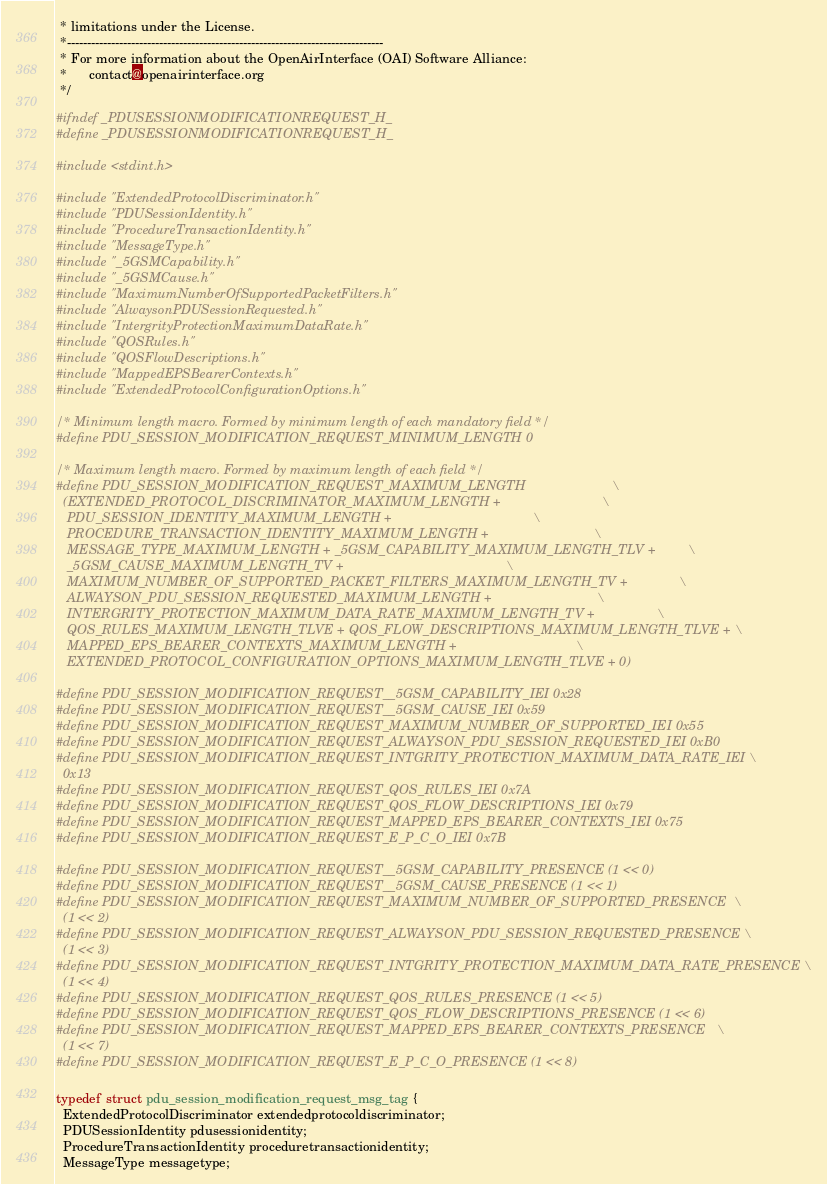Convert code to text. <code><loc_0><loc_0><loc_500><loc_500><_C_> * limitations under the License.
 *-------------------------------------------------------------------------------
 * For more information about the OpenAirInterface (OAI) Software Alliance:
 *      contact@openairinterface.org
 */

#ifndef _PDUSESSIONMODIFICATIONREQUEST_H_
#define _PDUSESSIONMODIFICATIONREQUEST_H_

#include <stdint.h>

#include "ExtendedProtocolDiscriminator.h"
#include "PDUSessionIdentity.h"
#include "ProcedureTransactionIdentity.h"
#include "MessageType.h"
#include "_5GSMCapability.h"
#include "_5GSMCause.h"
#include "MaximumNumberOfSupportedPacketFilters.h"
#include "AlwaysonPDUSessionRequested.h"
#include "IntergrityProtectionMaximumDataRate.h"
#include "QOSRules.h"
#include "QOSFlowDescriptions.h"
#include "MappedEPSBearerContexts.h"
#include "ExtendedProtocolConfigurationOptions.h"

/* Minimum length macro. Formed by minimum length of each mandatory field */
#define PDU_SESSION_MODIFICATION_REQUEST_MINIMUM_LENGTH 0

/* Maximum length macro. Formed by maximum length of each field */
#define PDU_SESSION_MODIFICATION_REQUEST_MAXIMUM_LENGTH                        \
  (EXTENDED_PROTOCOL_DISCRIMINATOR_MAXIMUM_LENGTH +                            \
   PDU_SESSION_IDENTITY_MAXIMUM_LENGTH +                                       \
   PROCEDURE_TRANSACTION_IDENTITY_MAXIMUM_LENGTH +                             \
   MESSAGE_TYPE_MAXIMUM_LENGTH + _5GSM_CAPABILITY_MAXIMUM_LENGTH_TLV +         \
   _5GSM_CAUSE_MAXIMUM_LENGTH_TV +                                             \
   MAXIMUM_NUMBER_OF_SUPPORTED_PACKET_FILTERS_MAXIMUM_LENGTH_TV +              \
   ALWAYSON_PDU_SESSION_REQUESTED_MAXIMUM_LENGTH +                             \
   INTERGRITY_PROTECTION_MAXIMUM_DATA_RATE_MAXIMUM_LENGTH_TV +                 \
   QOS_RULES_MAXIMUM_LENGTH_TLVE + QOS_FLOW_DESCRIPTIONS_MAXIMUM_LENGTH_TLVE + \
   MAPPED_EPS_BEARER_CONTEXTS_MAXIMUM_LENGTH +                                 \
   EXTENDED_PROTOCOL_CONFIGURATION_OPTIONS_MAXIMUM_LENGTH_TLVE + 0)

#define PDU_SESSION_MODIFICATION_REQUEST__5GSM_CAPABILITY_IEI 0x28
#define PDU_SESSION_MODIFICATION_REQUEST__5GSM_CAUSE_IEI 0x59
#define PDU_SESSION_MODIFICATION_REQUEST_MAXIMUM_NUMBER_OF_SUPPORTED_IEI 0x55
#define PDU_SESSION_MODIFICATION_REQUEST_ALWAYSON_PDU_SESSION_REQUESTED_IEI 0xB0
#define PDU_SESSION_MODIFICATION_REQUEST_INTGRITY_PROTECTION_MAXIMUM_DATA_RATE_IEI \
  0x13
#define PDU_SESSION_MODIFICATION_REQUEST_QOS_RULES_IEI 0x7A
#define PDU_SESSION_MODIFICATION_REQUEST_QOS_FLOW_DESCRIPTIONS_IEI 0x79
#define PDU_SESSION_MODIFICATION_REQUEST_MAPPED_EPS_BEARER_CONTEXTS_IEI 0x75
#define PDU_SESSION_MODIFICATION_REQUEST_E_P_C_O_IEI 0x7B

#define PDU_SESSION_MODIFICATION_REQUEST__5GSM_CAPABILITY_PRESENCE (1 << 0)
#define PDU_SESSION_MODIFICATION_REQUEST__5GSM_CAUSE_PRESENCE (1 << 1)
#define PDU_SESSION_MODIFICATION_REQUEST_MAXIMUM_NUMBER_OF_SUPPORTED_PRESENCE  \
  (1 << 2)
#define PDU_SESSION_MODIFICATION_REQUEST_ALWAYSON_PDU_SESSION_REQUESTED_PRESENCE \
  (1 << 3)
#define PDU_SESSION_MODIFICATION_REQUEST_INTGRITY_PROTECTION_MAXIMUM_DATA_RATE_PRESENCE \
  (1 << 4)
#define PDU_SESSION_MODIFICATION_REQUEST_QOS_RULES_PRESENCE (1 << 5)
#define PDU_SESSION_MODIFICATION_REQUEST_QOS_FLOW_DESCRIPTIONS_PRESENCE (1 << 6)
#define PDU_SESSION_MODIFICATION_REQUEST_MAPPED_EPS_BEARER_CONTEXTS_PRESENCE   \
  (1 << 7)
#define PDU_SESSION_MODIFICATION_REQUEST_E_P_C_O_PRESENCE (1 << 8)

typedef struct pdu_session_modification_request_msg_tag {
  ExtendedProtocolDiscriminator extendedprotocoldiscriminator;
  PDUSessionIdentity pdusessionidentity;
  ProcedureTransactionIdentity proceduretransactionidentity;
  MessageType messagetype;</code> 